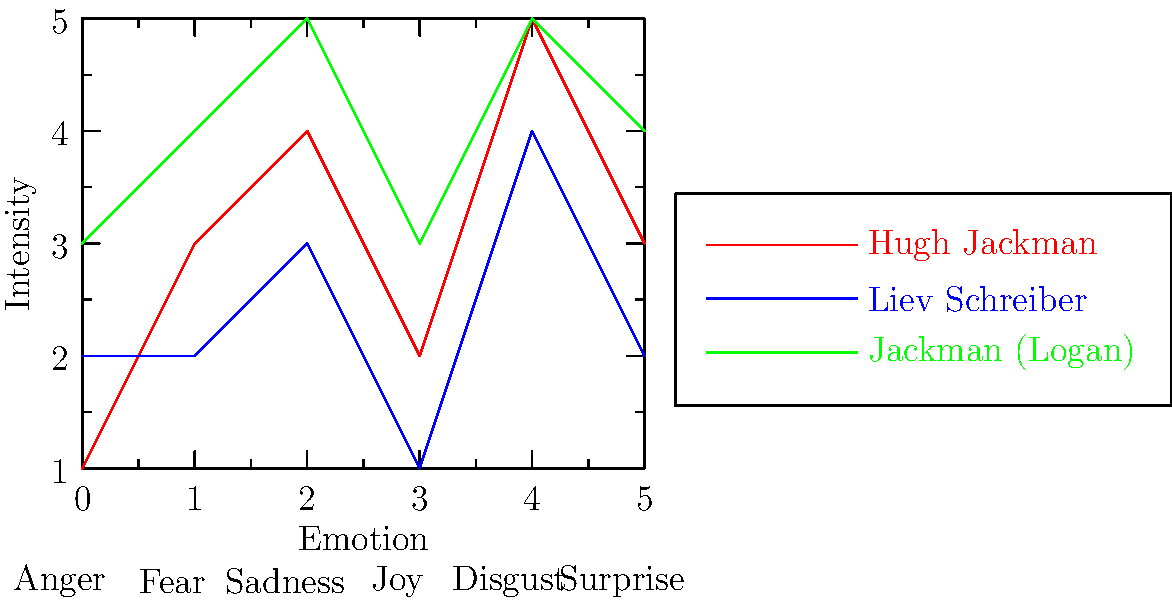Based on the facial expression chart comparing different Wolverine portrayals, which actor's portrayal demonstrates the highest average emotional intensity across all emotions, and how does this relate to the character's development in the X-Men film franchise? To answer this question, we need to analyze the chart and follow these steps:

1. Identify the actors and their corresponding lines:
   - Red line: Hugh Jackman (earlier portrayal)
   - Blue line: Liev Schreiber (as Victor Creed/Sabretooth in X-Men Origins: Wolverine)
   - Green line: Jackman (Logan)

2. Calculate the average emotional intensity for each portrayal:
   - Hugh Jackman (earlier): $(1+3+4+2+5+3)/6 = 3$
   - Liev Schreiber: $(2+2+3+1+4+2)/6 = 2.33$
   - Jackman (Logan): $(3+4+5+3+5+4)/6 = 4$

3. Determine the highest average:
   Jackman's portrayal in "Logan" has the highest average emotional intensity at 4.

4. Relate this to character development:
   The higher emotional intensity in "Logan" reflects the character's evolution throughout the franchise. In this final installment, Wolverine is older, more world-weary, and facing his own mortality. This results in a more emotionally complex and intense performance, showcasing a broader range of feelings compared to earlier portrayals.

5. Compare to other portrayals:
   - Earlier Jackman portrayal shows moderate intensity, reflecting the character's initial development and struggle with his identity.
   - Liev Schreiber's portrayal (as Sabretooth) shows the lowest intensity, possibly due to the character's more antagonistic and less emotionally expressive nature.

The progression of emotional intensity in Jackman's portrayals (from red to green line) demonstrates the character's growth and the actor's deepening understanding of Wolverine over time.
Answer: Jackman (Logan), with an average intensity of 4, reflecting Wolverine's emotional evolution throughout the franchise. 